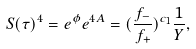Convert formula to latex. <formula><loc_0><loc_0><loc_500><loc_500>S ( \tau ) ^ { 4 } = e ^ { \phi } e ^ { 4 A } = ( \frac { f _ { - } } { f _ { + } } ) ^ { c _ { 1 } } \frac { 1 } { Y } ,</formula> 